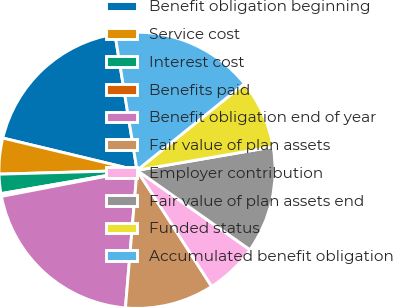<chart> <loc_0><loc_0><loc_500><loc_500><pie_chart><fcel>Benefit obligation beginning<fcel>Service cost<fcel>Interest cost<fcel>Benefits paid<fcel>Benefit obligation end of year<fcel>Fair value of plan assets<fcel>Employer contribution<fcel>Fair value of plan assets end<fcel>Funded status<fcel>Accumulated benefit obligation<nl><fcel>18.69%<fcel>4.2%<fcel>2.26%<fcel>0.32%<fcel>20.64%<fcel>10.43%<fcel>6.15%<fcel>12.48%<fcel>8.09%<fcel>16.75%<nl></chart> 